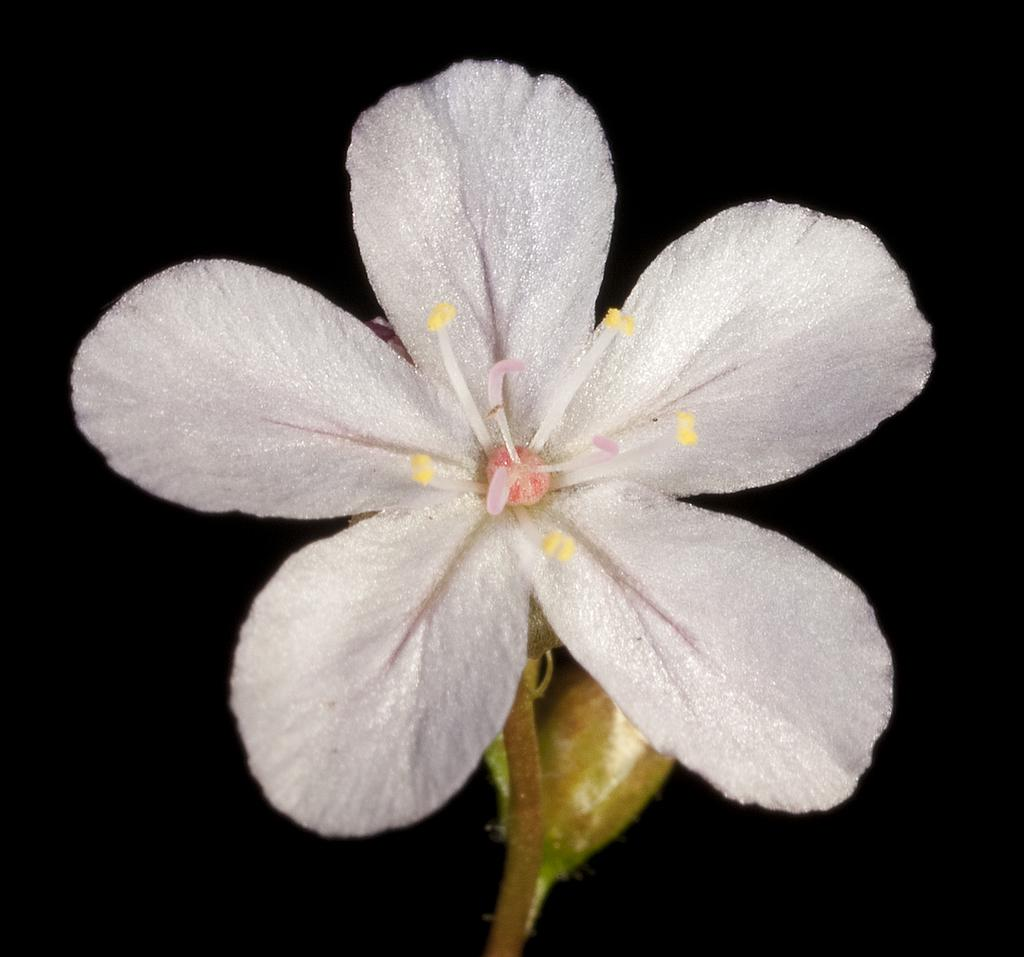What is the general color scheme of the image? The background of the image is dark. What type of living organism can be seen in the image? There is a plant in the image. What is the color of the flower on the plant? The plant has a beautiful white color flower. What type of cup is being used to water the plant in the image? There is no cup present in the image, and therefore no such activity can be observed. 